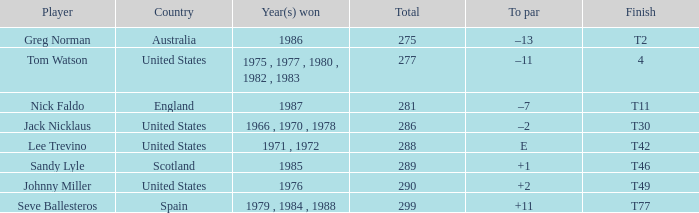What's england's to par? –7. 